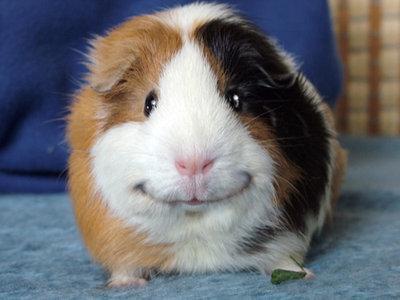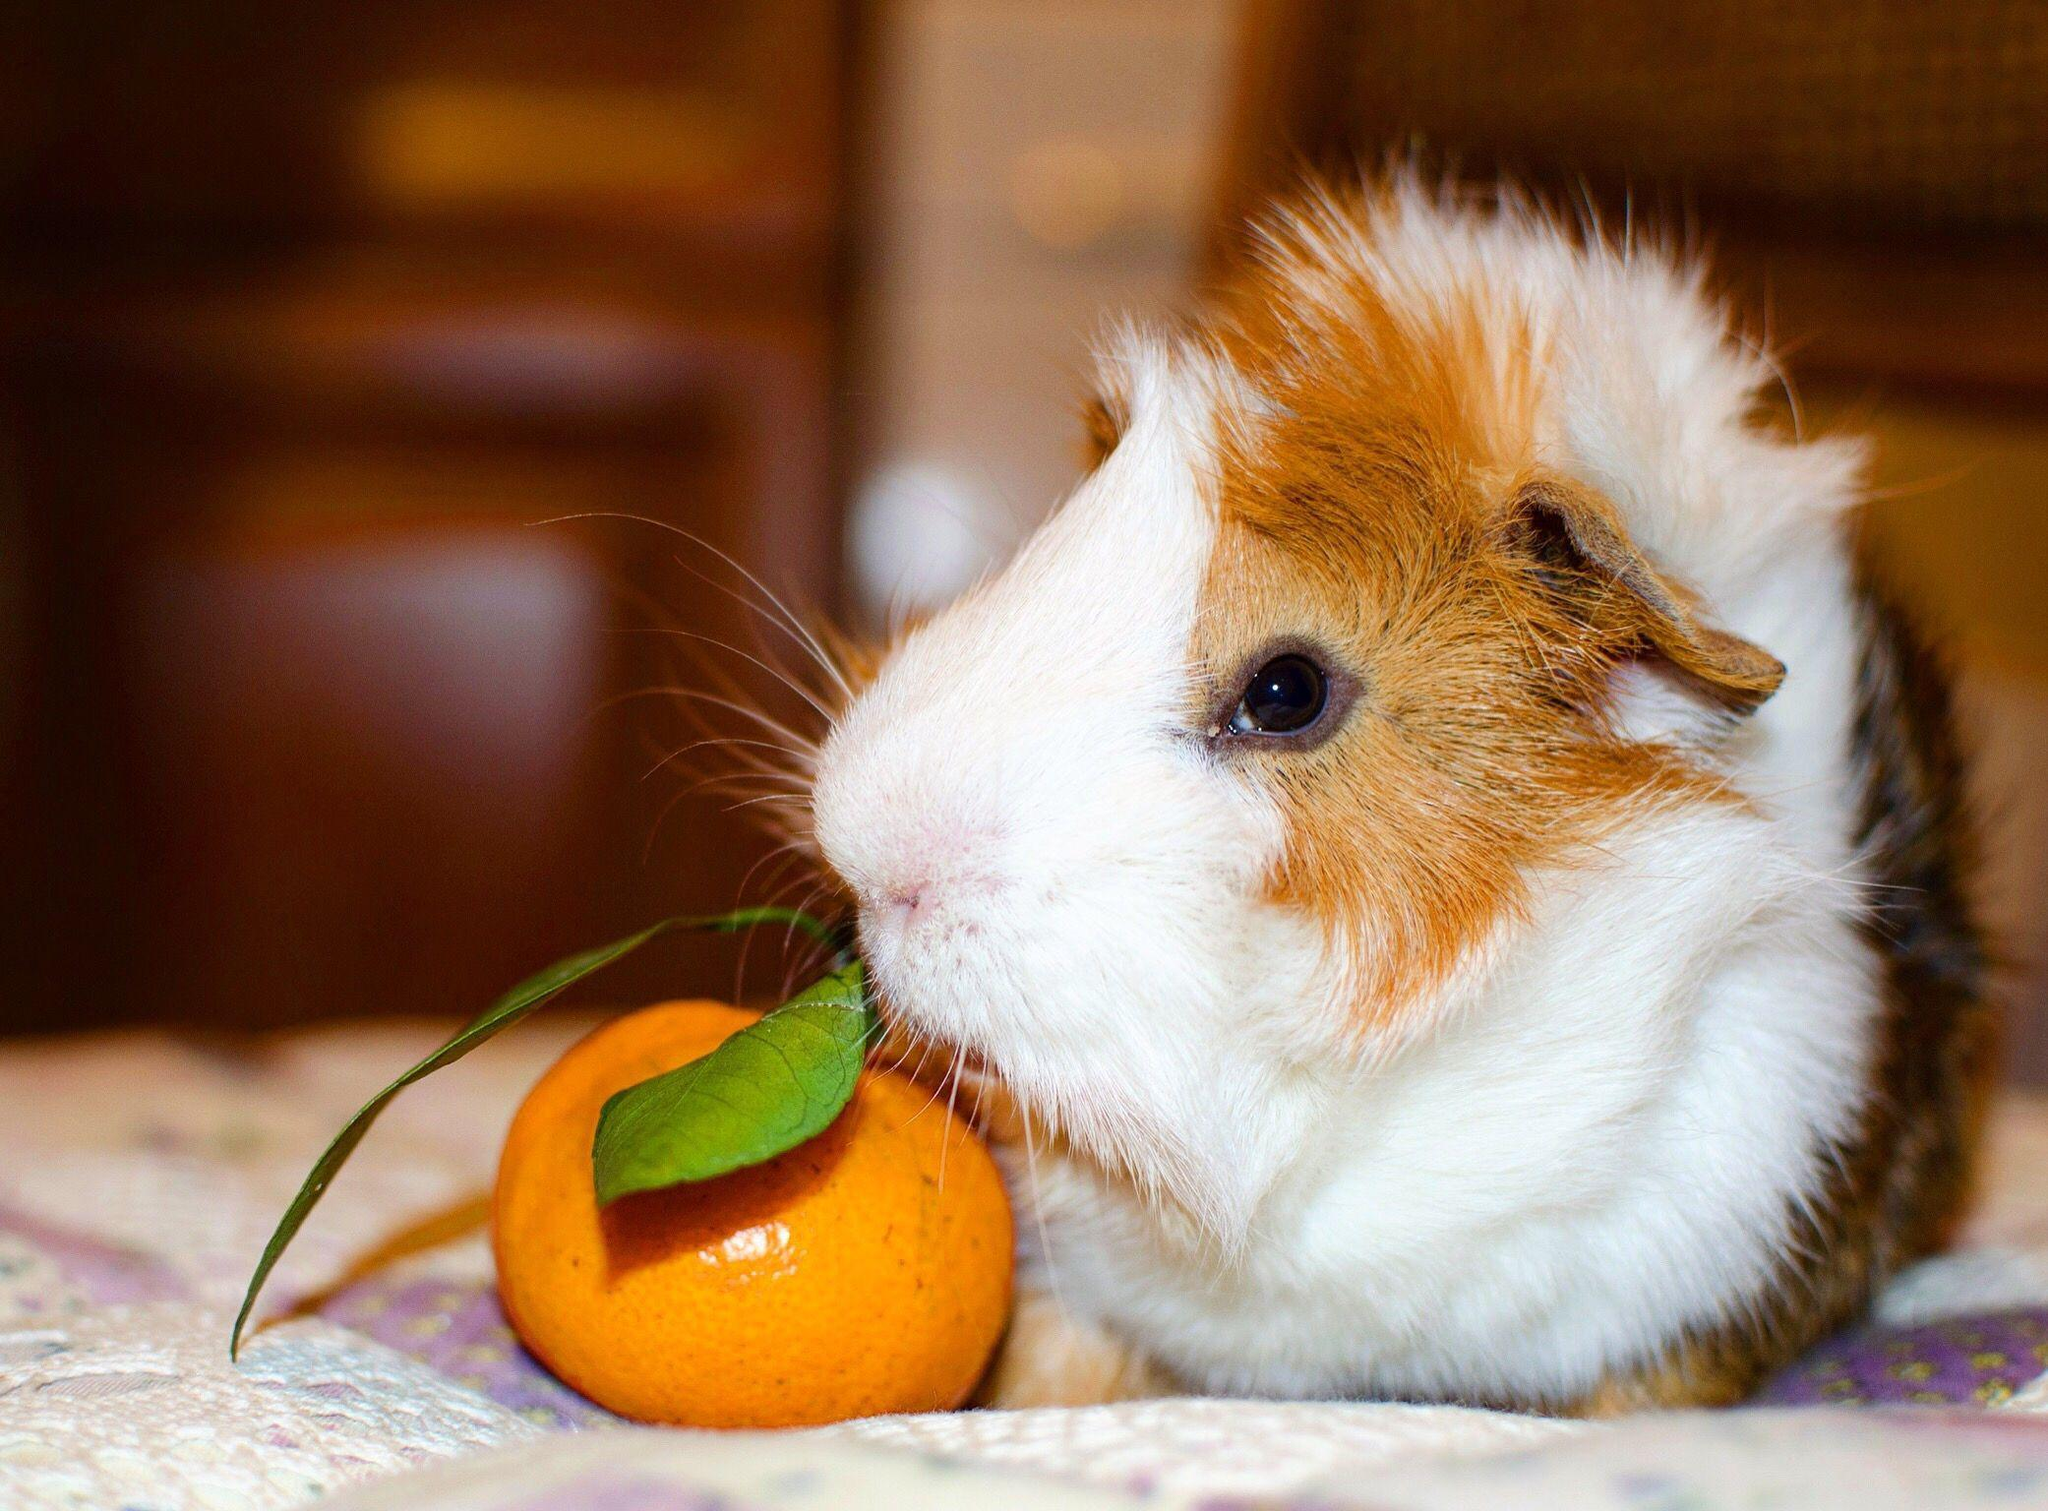The first image is the image on the left, the second image is the image on the right. Evaluate the accuracy of this statement regarding the images: "The hamster on the right is depicted with produce-type food.". Is it true? Answer yes or no. Yes. 